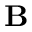Convert formula to latex. <formula><loc_0><loc_0><loc_500><loc_500>B</formula> 